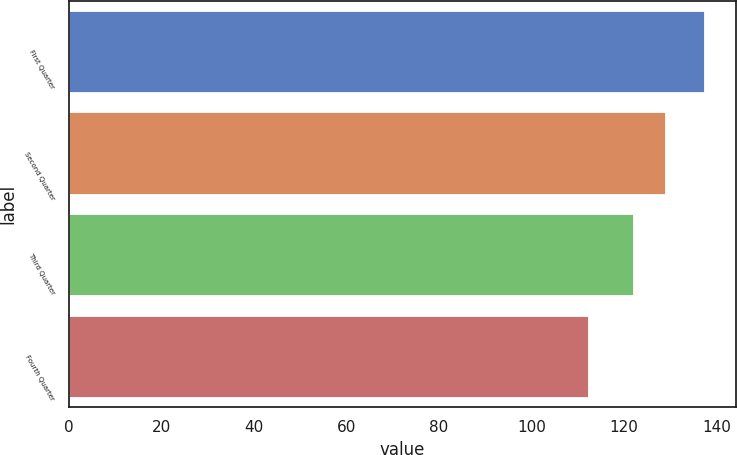<chart> <loc_0><loc_0><loc_500><loc_500><bar_chart><fcel>First Quarter<fcel>Second Quarter<fcel>Third Quarter<fcel>Fourth Quarter<nl><fcel>137.27<fcel>128.82<fcel>121.91<fcel>112.16<nl></chart> 